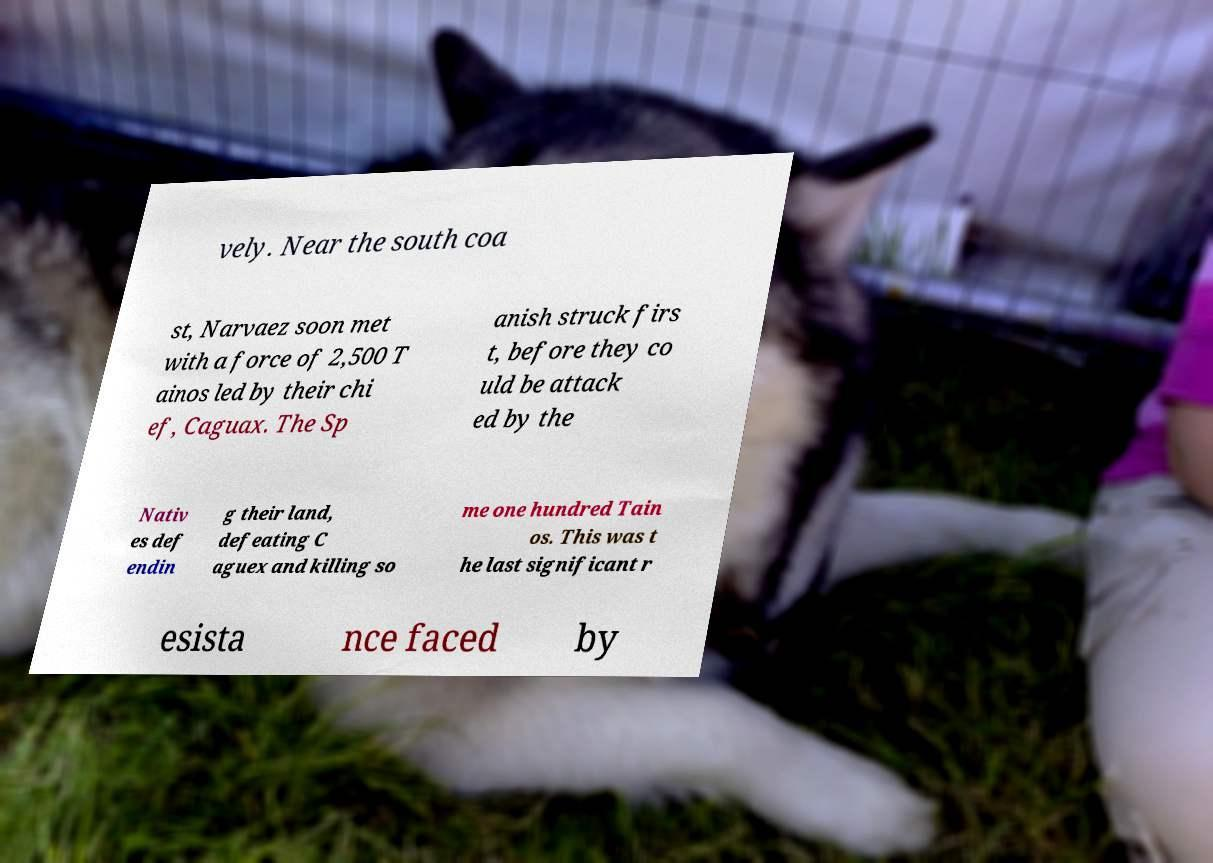There's text embedded in this image that I need extracted. Can you transcribe it verbatim? vely. Near the south coa st, Narvaez soon met with a force of 2,500 T ainos led by their chi ef, Caguax. The Sp anish struck firs t, before they co uld be attack ed by the Nativ es def endin g their land, defeating C aguex and killing so me one hundred Tain os. This was t he last significant r esista nce faced by 